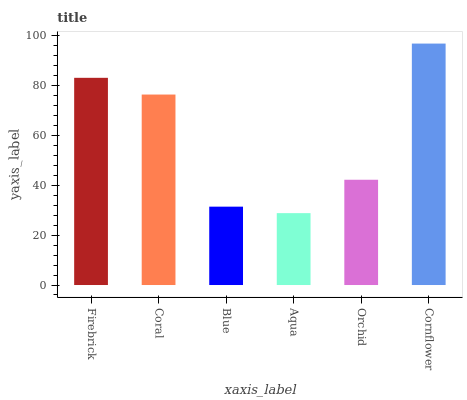Is Coral the minimum?
Answer yes or no. No. Is Coral the maximum?
Answer yes or no. No. Is Firebrick greater than Coral?
Answer yes or no. Yes. Is Coral less than Firebrick?
Answer yes or no. Yes. Is Coral greater than Firebrick?
Answer yes or no. No. Is Firebrick less than Coral?
Answer yes or no. No. Is Coral the high median?
Answer yes or no. Yes. Is Orchid the low median?
Answer yes or no. Yes. Is Orchid the high median?
Answer yes or no. No. Is Cornflower the low median?
Answer yes or no. No. 